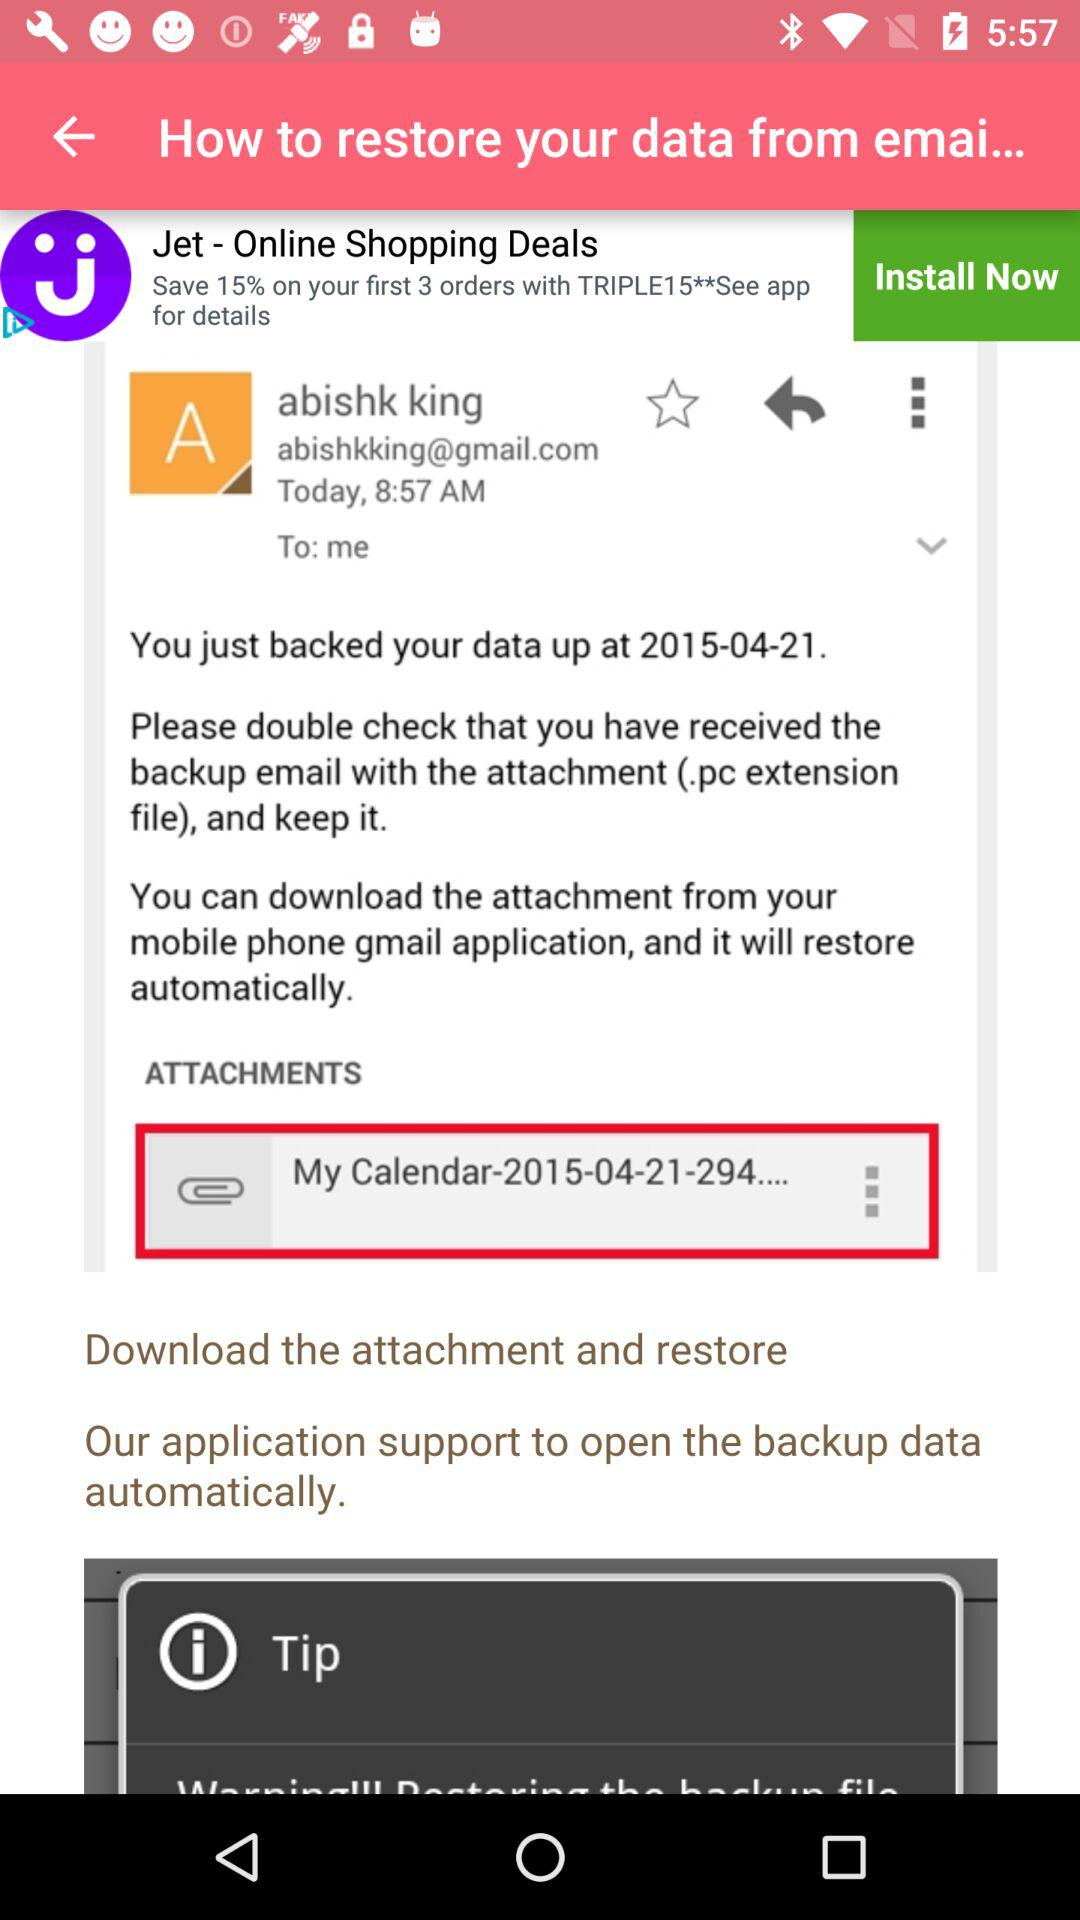Who sent the email? The email was sent by Abishk King. 